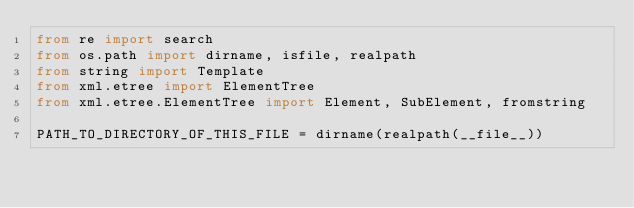Convert code to text. <code><loc_0><loc_0><loc_500><loc_500><_Python_>from re import search
from os.path import dirname, isfile, realpath
from string import Template
from xml.etree import ElementTree
from xml.etree.ElementTree import Element, SubElement, fromstring

PATH_TO_DIRECTORY_OF_THIS_FILE = dirname(realpath(__file__))
</code> 